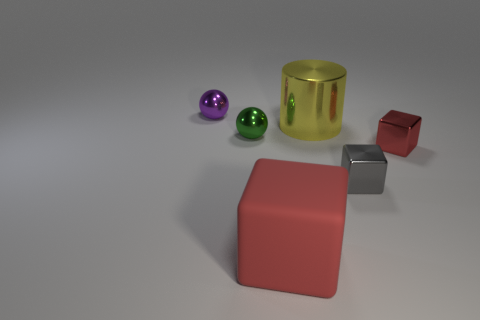Add 2 gray metallic cubes. How many objects exist? 8 Subtract all cylinders. How many objects are left? 5 Add 5 rubber blocks. How many rubber blocks exist? 6 Subtract 0 cyan cylinders. How many objects are left? 6 Subtract all green shiny objects. Subtract all yellow cylinders. How many objects are left? 4 Add 4 green shiny objects. How many green shiny objects are left? 5 